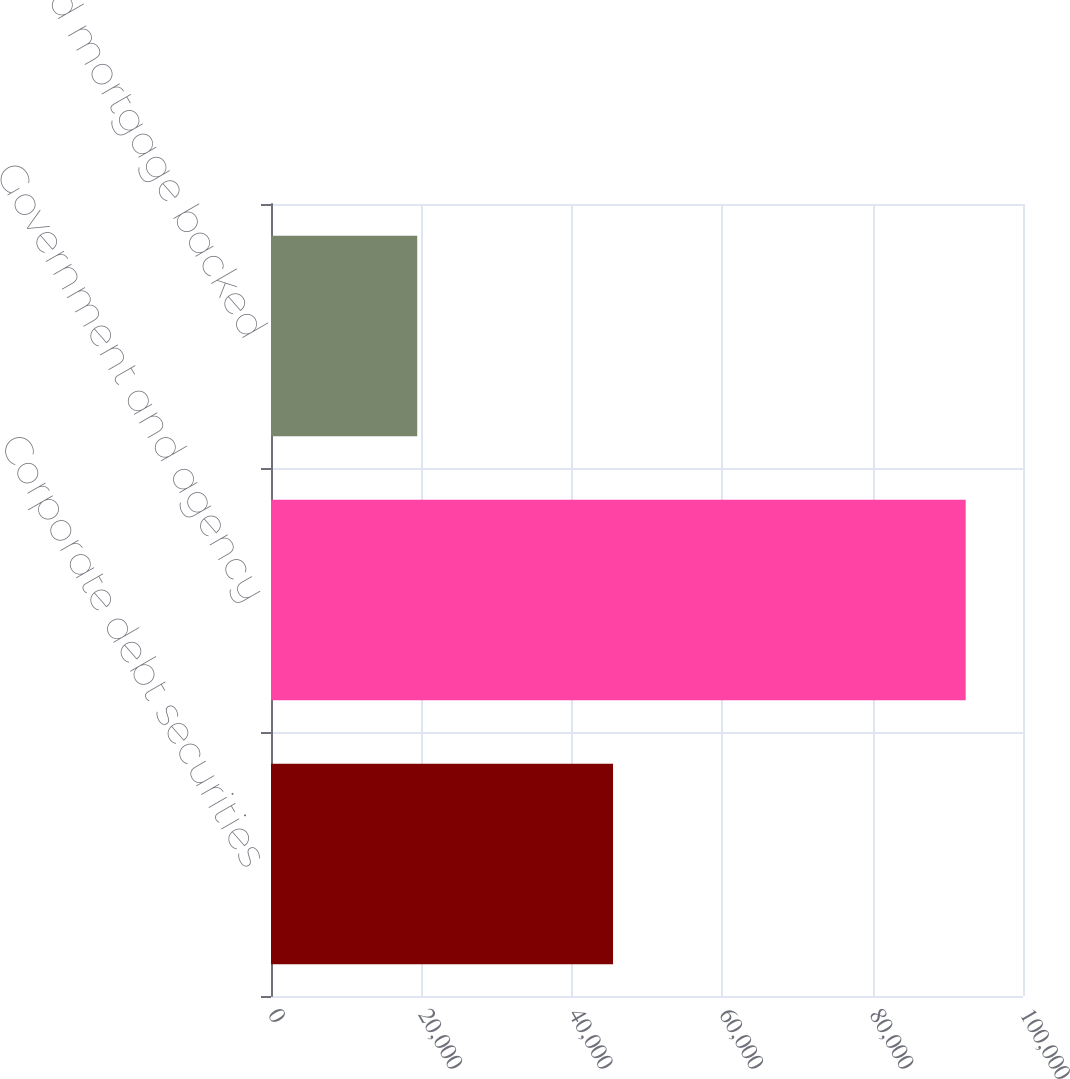<chart> <loc_0><loc_0><loc_500><loc_500><bar_chart><fcel>Corporate debt securities<fcel>Government and agency<fcel>Asset and mortgage backed<nl><fcel>45482<fcel>92378<fcel>19446<nl></chart> 